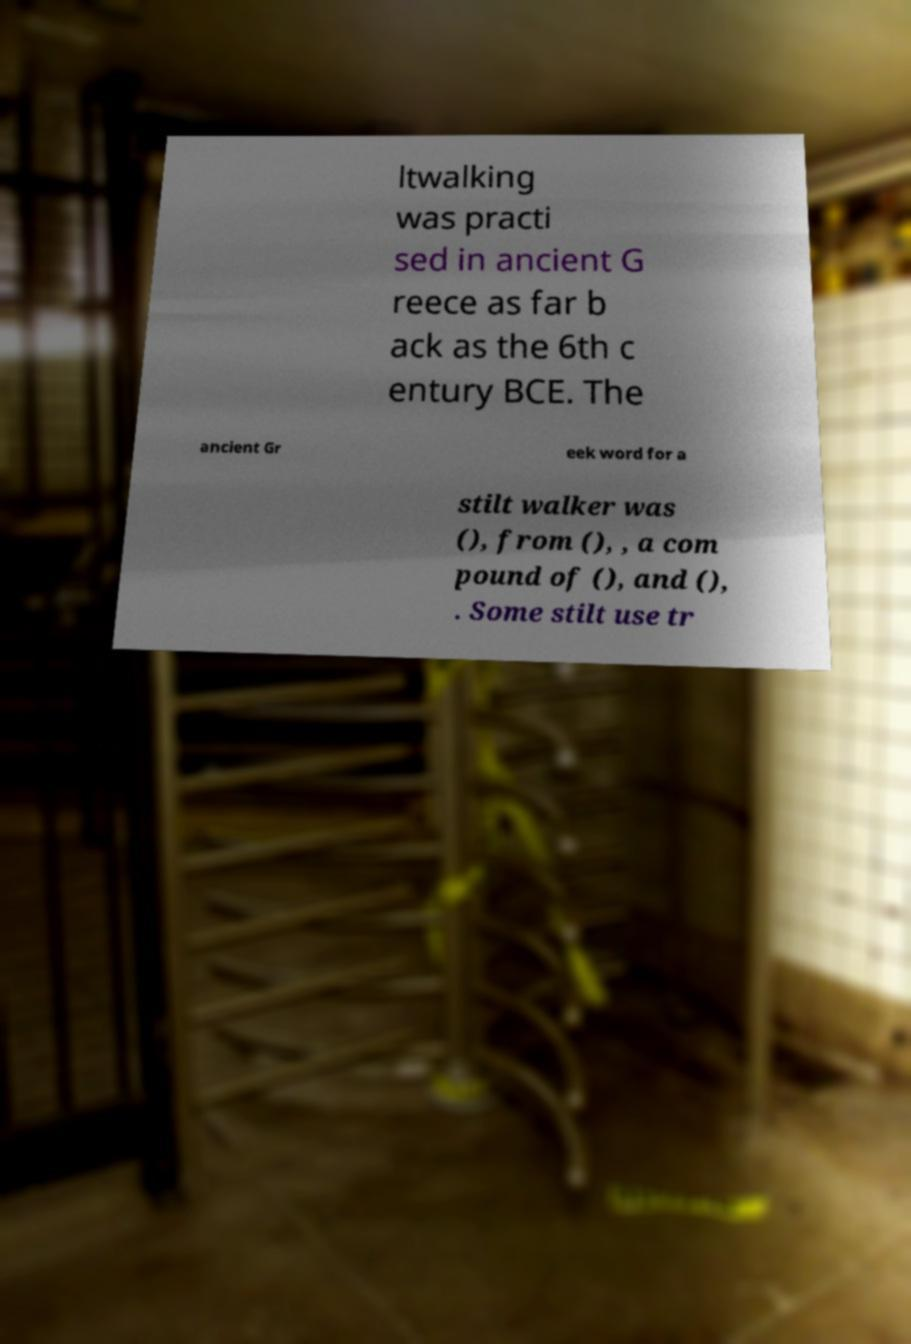Please read and relay the text visible in this image. What does it say? ltwalking was practi sed in ancient G reece as far b ack as the 6th c entury BCE. The ancient Gr eek word for a stilt walker was (), from (), , a com pound of (), and (), . Some stilt use tr 